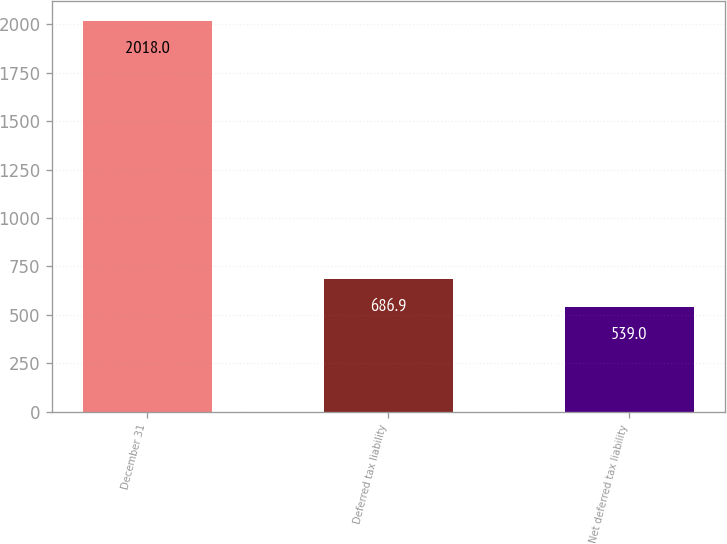<chart> <loc_0><loc_0><loc_500><loc_500><bar_chart><fcel>December 31<fcel>Deferred tax liability<fcel>Net deferred tax liability<nl><fcel>2018<fcel>686.9<fcel>539<nl></chart> 